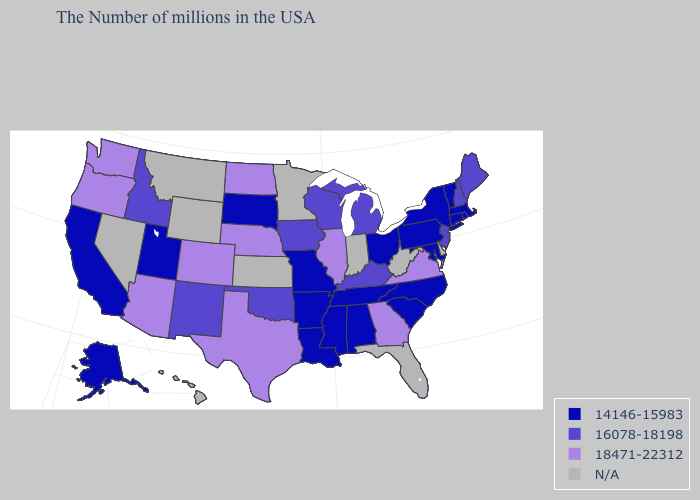What is the value of Utah?
Concise answer only. 14146-15983. Is the legend a continuous bar?
Quick response, please. No. Does the map have missing data?
Give a very brief answer. Yes. What is the value of Kentucky?
Be succinct. 16078-18198. What is the lowest value in the Northeast?
Quick response, please. 14146-15983. What is the value of Hawaii?
Answer briefly. N/A. Among the states that border Idaho , does Oregon have the highest value?
Keep it brief. Yes. Does the map have missing data?
Keep it brief. Yes. Name the states that have a value in the range 14146-15983?
Give a very brief answer. Massachusetts, Rhode Island, Vermont, Connecticut, New York, Maryland, Pennsylvania, North Carolina, South Carolina, Ohio, Alabama, Tennessee, Mississippi, Louisiana, Missouri, Arkansas, South Dakota, Utah, California, Alaska. Name the states that have a value in the range N/A?
Keep it brief. Delaware, West Virginia, Florida, Indiana, Minnesota, Kansas, Wyoming, Montana, Nevada, Hawaii. Does Texas have the highest value in the South?
Be succinct. Yes. Name the states that have a value in the range 18471-22312?
Give a very brief answer. Virginia, Georgia, Illinois, Nebraska, Texas, North Dakota, Colorado, Arizona, Washington, Oregon. Does Pennsylvania have the lowest value in the USA?
Be succinct. Yes. 